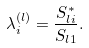Convert formula to latex. <formula><loc_0><loc_0><loc_500><loc_500>\lambda _ { i } ^ { ( l ) } = \frac { S _ { l i } ^ { * } } { S _ { l 1 } } .</formula> 